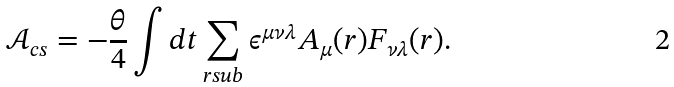Convert formula to latex. <formula><loc_0><loc_0><loc_500><loc_500>\mathcal { A } _ { c s } = - \frac { \theta } { 4 } \int d t \sum _ { r s u b } \epsilon ^ { \mu \nu \lambda } A _ { \mu } ( r ) F _ { \nu \lambda } ( r ) .</formula> 